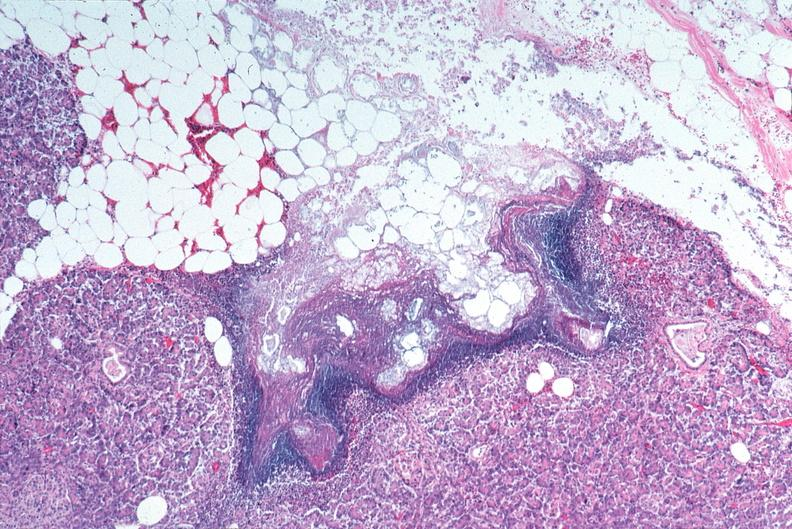where is this?
Answer the question using a single word or phrase. Pancreas 